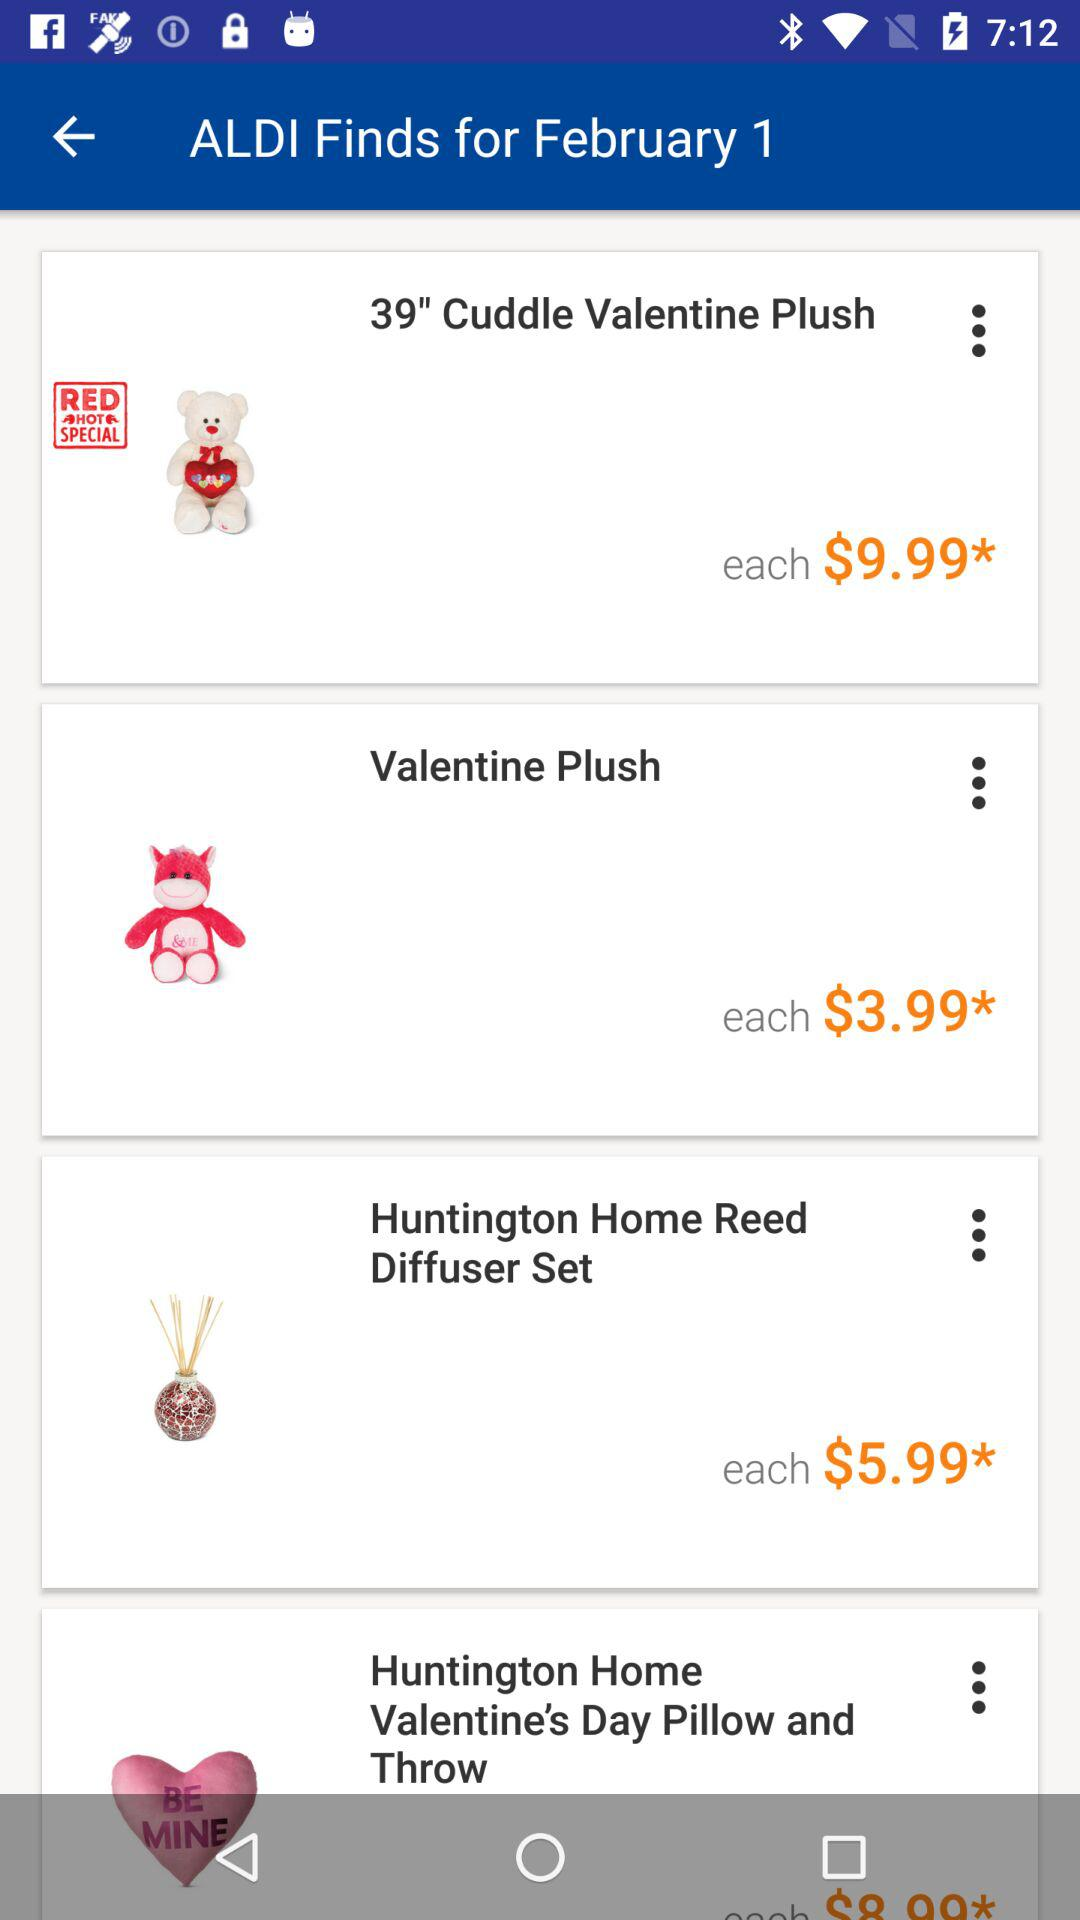What is the date? The date is February 1. 